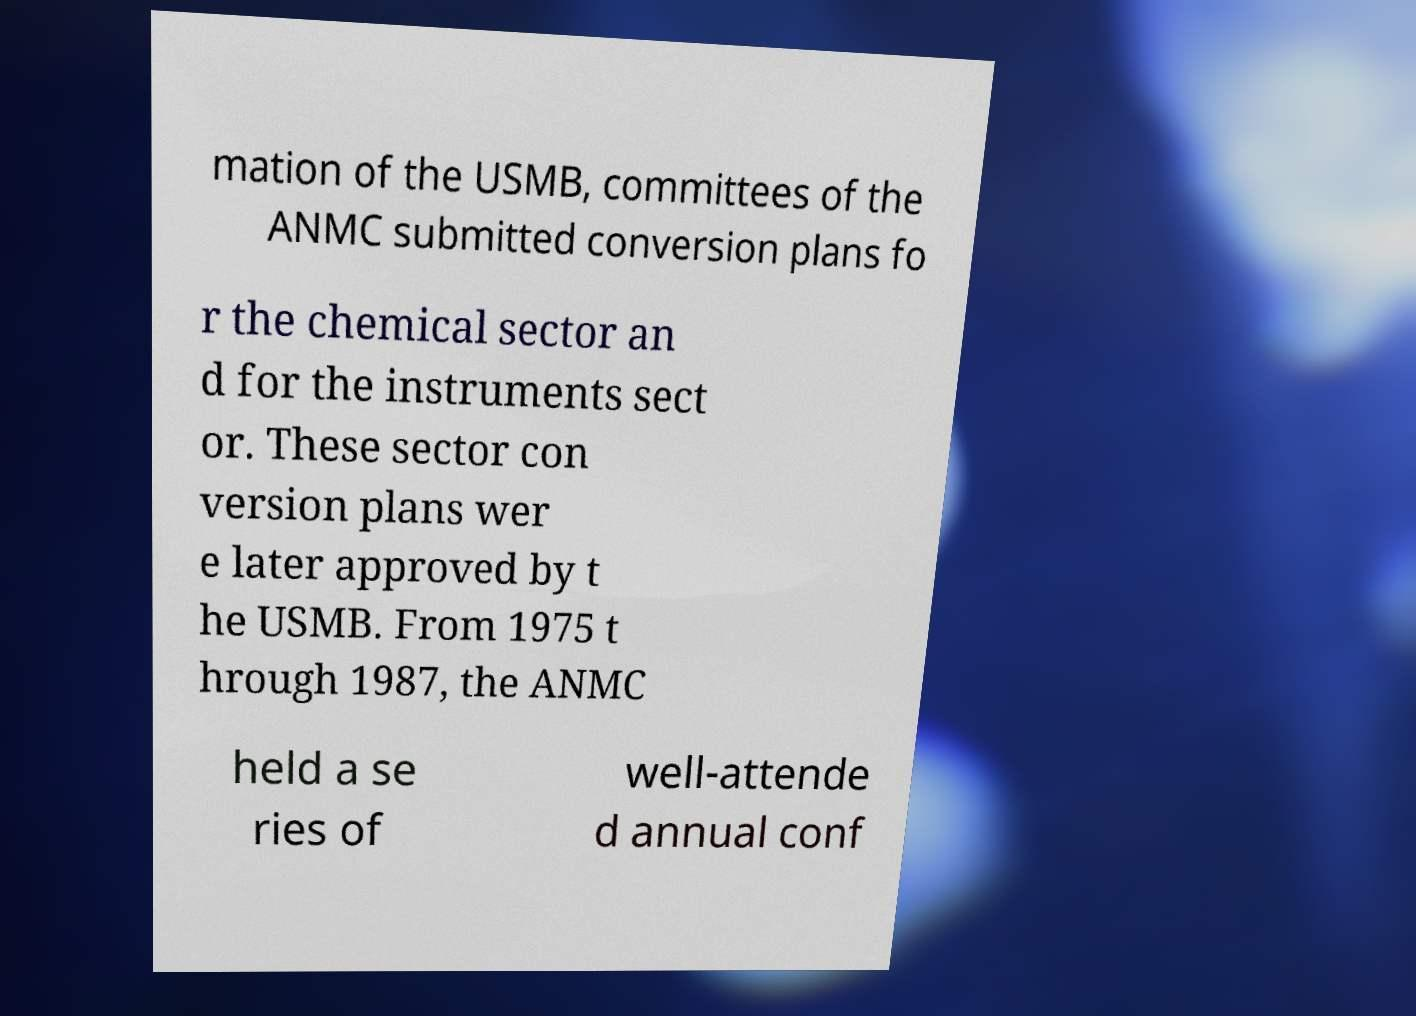Could you extract and type out the text from this image? mation of the USMB, committees of the ANMC submitted conversion plans fo r the chemical sector an d for the instruments sect or. These sector con version plans wer e later approved by t he USMB. From 1975 t hrough 1987, the ANMC held a se ries of well-attende d annual conf 